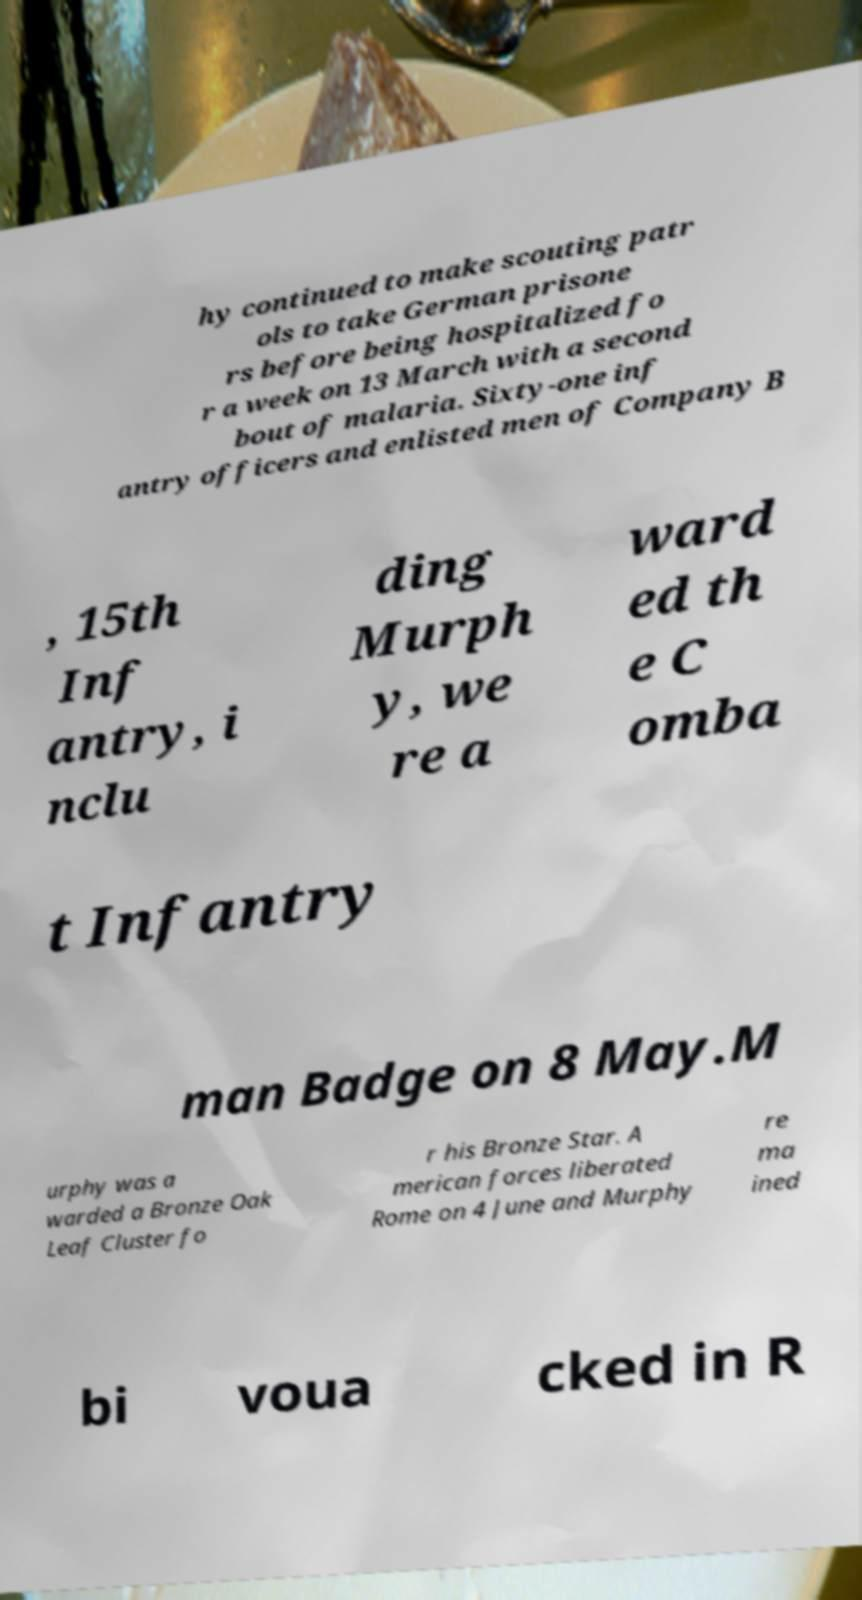Please identify and transcribe the text found in this image. hy continued to make scouting patr ols to take German prisone rs before being hospitalized fo r a week on 13 March with a second bout of malaria. Sixty-one inf antry officers and enlisted men of Company B , 15th Inf antry, i nclu ding Murph y, we re a ward ed th e C omba t Infantry man Badge on 8 May.M urphy was a warded a Bronze Oak Leaf Cluster fo r his Bronze Star. A merican forces liberated Rome on 4 June and Murphy re ma ined bi voua cked in R 